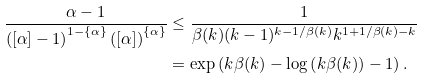<formula> <loc_0><loc_0><loc_500><loc_500>\frac { \alpha - 1 } { \left ( [ \alpha ] - 1 \right ) ^ { 1 - \{ \alpha \} } \left ( [ \alpha ] \right ) ^ { \{ \alpha \} } } & \leq \frac { 1 } { \beta ( k ) ( k - 1 ) ^ { k - 1 / \beta ( k ) } k ^ { 1 + 1 / \beta ( k ) - k } } \\ & = \exp \left ( k \beta ( k ) - \log \left ( k \beta ( k ) \right ) - 1 \right ) .</formula> 